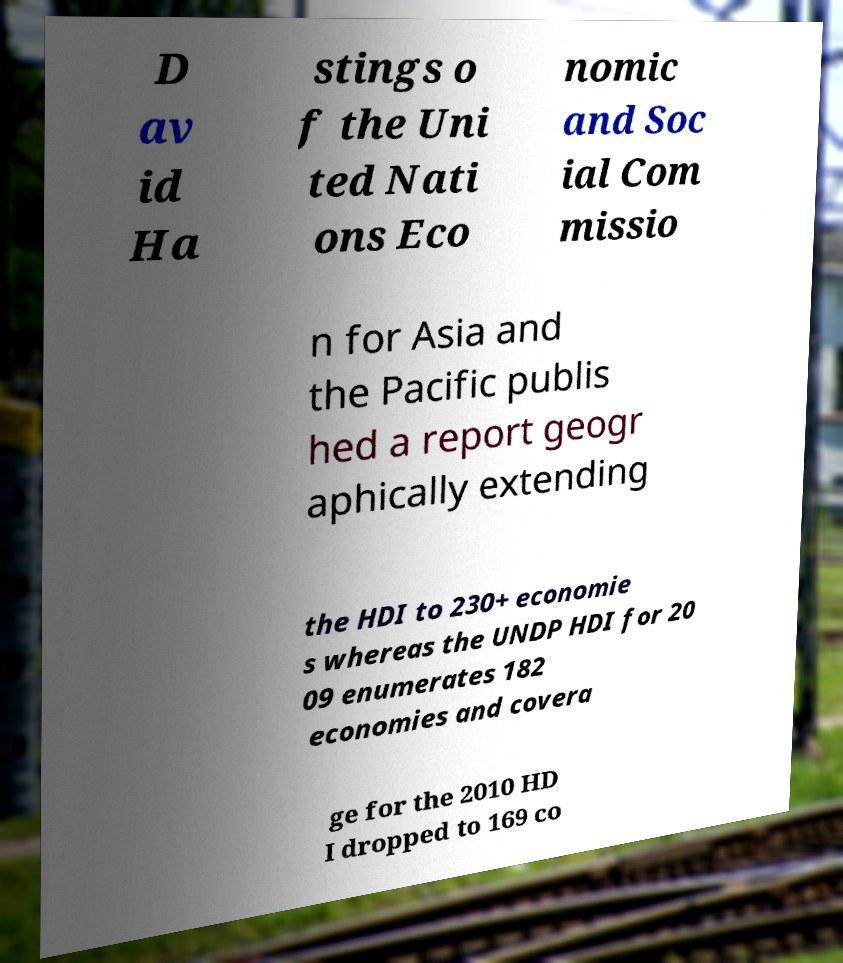Please read and relay the text visible in this image. What does it say? D av id Ha stings o f the Uni ted Nati ons Eco nomic and Soc ial Com missio n for Asia and the Pacific publis hed a report geogr aphically extending the HDI to 230+ economie s whereas the UNDP HDI for 20 09 enumerates 182 economies and covera ge for the 2010 HD I dropped to 169 co 